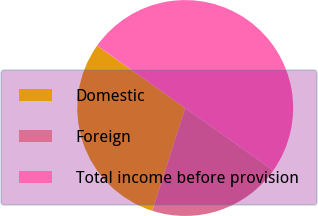Convert chart to OTSL. <chart><loc_0><loc_0><loc_500><loc_500><pie_chart><fcel>Domestic<fcel>Foreign<fcel>Total income before provision<nl><fcel>29.88%<fcel>20.12%<fcel>50.0%<nl></chart> 